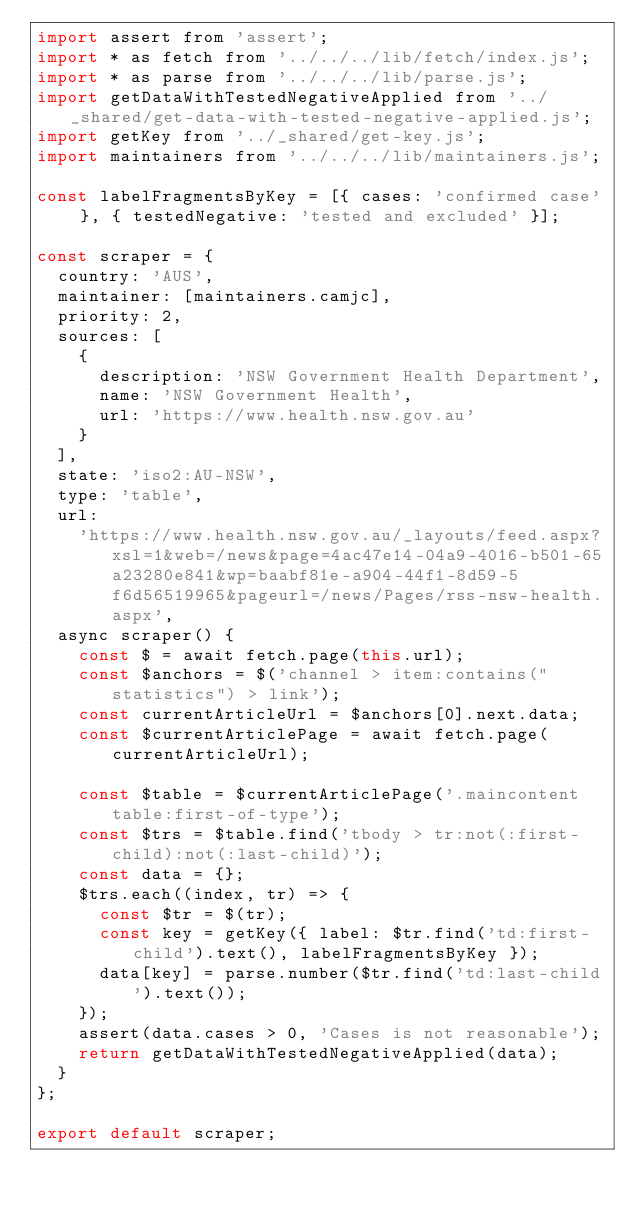<code> <loc_0><loc_0><loc_500><loc_500><_JavaScript_>import assert from 'assert';
import * as fetch from '../../../lib/fetch/index.js';
import * as parse from '../../../lib/parse.js';
import getDataWithTestedNegativeApplied from '../_shared/get-data-with-tested-negative-applied.js';
import getKey from '../_shared/get-key.js';
import maintainers from '../../../lib/maintainers.js';

const labelFragmentsByKey = [{ cases: 'confirmed case' }, { testedNegative: 'tested and excluded' }];

const scraper = {
  country: 'AUS',
  maintainer: [maintainers.camjc],
  priority: 2,
  sources: [
    {
      description: 'NSW Government Health Department',
      name: 'NSW Government Health',
      url: 'https://www.health.nsw.gov.au'
    }
  ],
  state: 'iso2:AU-NSW',
  type: 'table',
  url:
    'https://www.health.nsw.gov.au/_layouts/feed.aspx?xsl=1&web=/news&page=4ac47e14-04a9-4016-b501-65a23280e841&wp=baabf81e-a904-44f1-8d59-5f6d56519965&pageurl=/news/Pages/rss-nsw-health.aspx',
  async scraper() {
    const $ = await fetch.page(this.url);
    const $anchors = $('channel > item:contains("statistics") > link');
    const currentArticleUrl = $anchors[0].next.data;
    const $currentArticlePage = await fetch.page(currentArticleUrl);

    const $table = $currentArticlePage('.maincontent table:first-of-type');
    const $trs = $table.find('tbody > tr:not(:first-child):not(:last-child)');
    const data = {};
    $trs.each((index, tr) => {
      const $tr = $(tr);
      const key = getKey({ label: $tr.find('td:first-child').text(), labelFragmentsByKey });
      data[key] = parse.number($tr.find('td:last-child').text());
    });
    assert(data.cases > 0, 'Cases is not reasonable');
    return getDataWithTestedNegativeApplied(data);
  }
};

export default scraper;
</code> 